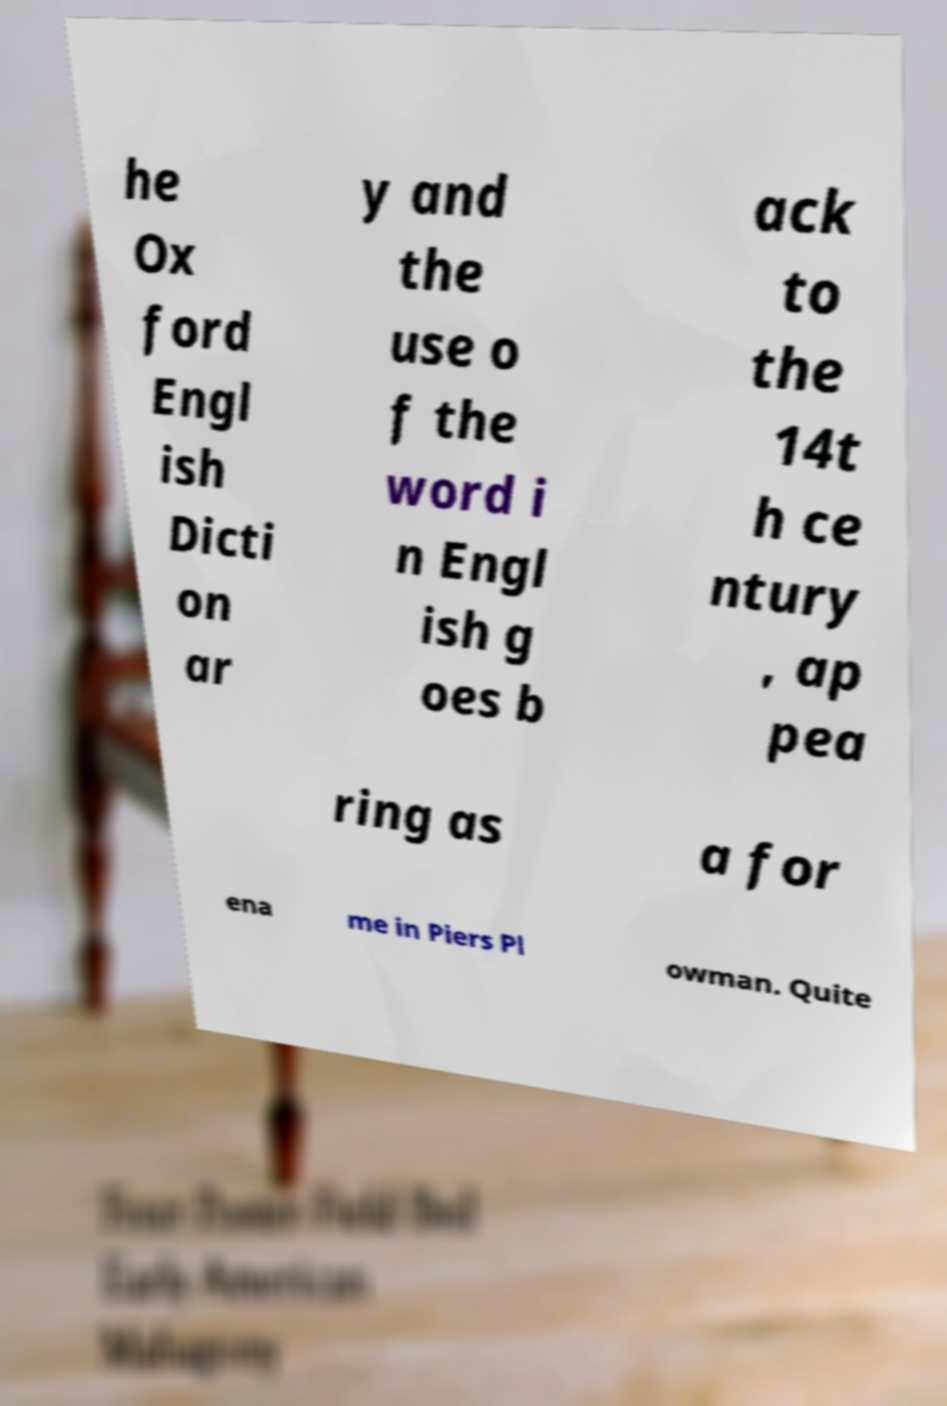Please identify and transcribe the text found in this image. he Ox ford Engl ish Dicti on ar y and the use o f the word i n Engl ish g oes b ack to the 14t h ce ntury , ap pea ring as a for ena me in Piers Pl owman. Quite 